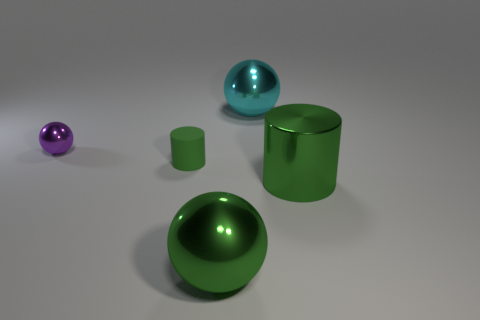Add 5 large rubber spheres. How many objects exist? 10 Subtract all spheres. How many objects are left? 2 Subtract 0 cyan blocks. How many objects are left? 5 Subtract all big green cylinders. Subtract all cyan metallic objects. How many objects are left? 3 Add 3 purple shiny things. How many purple shiny things are left? 4 Add 1 big green shiny cylinders. How many big green shiny cylinders exist? 2 